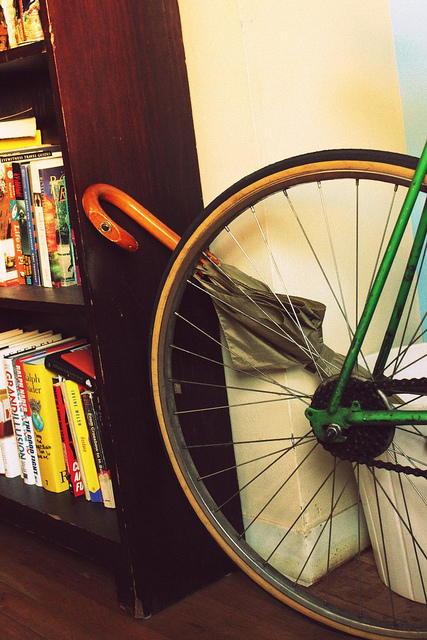Is there anything unique about the bookshelf arrangement? Aside from the intriguing juxtaposition of the bicycle wheel against the bookshelf, the arrangement of books by size, with larger books on the bottom, speaks to a functional organization method. Additionally, there's a harmonious color coordination that suggests careful curation. 